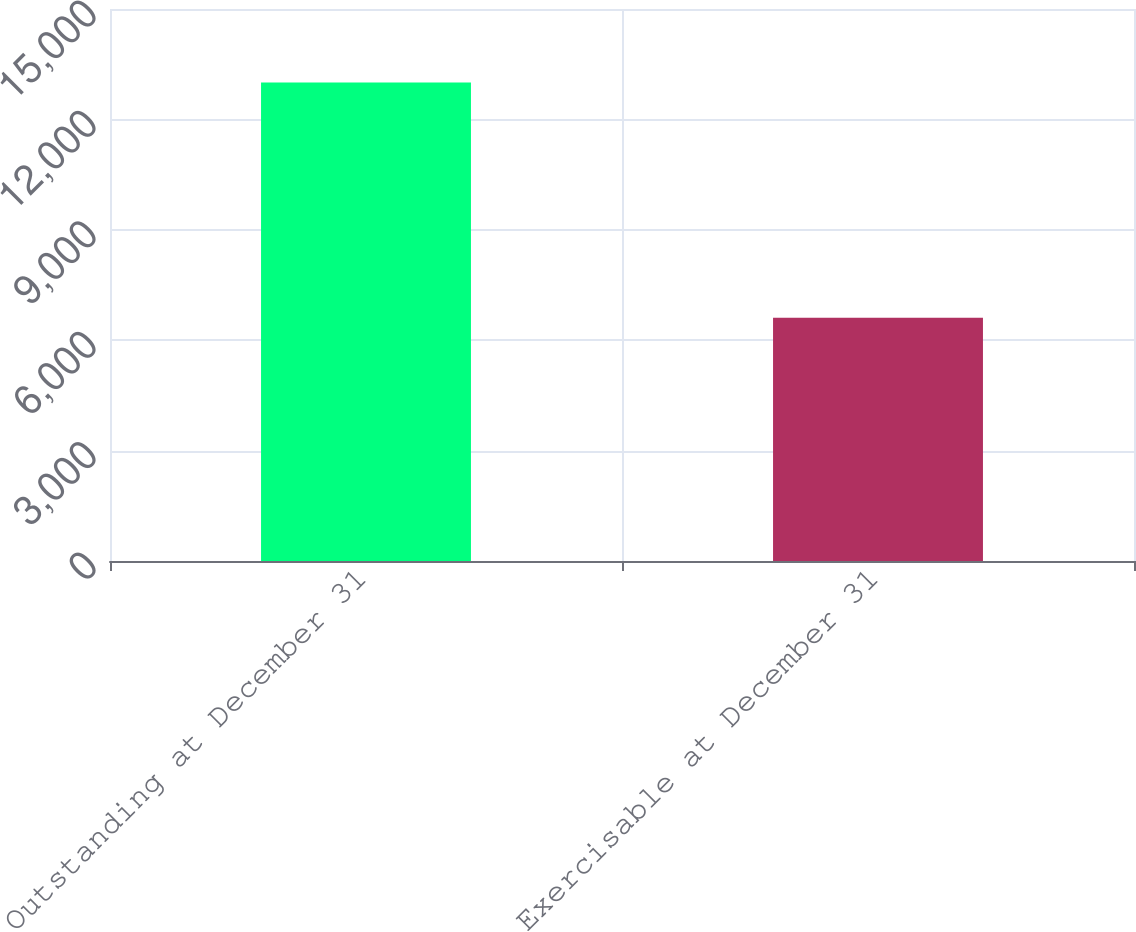Convert chart. <chart><loc_0><loc_0><loc_500><loc_500><bar_chart><fcel>Outstanding at December 31<fcel>Exercisable at December 31<nl><fcel>13004<fcel>6609<nl></chart> 